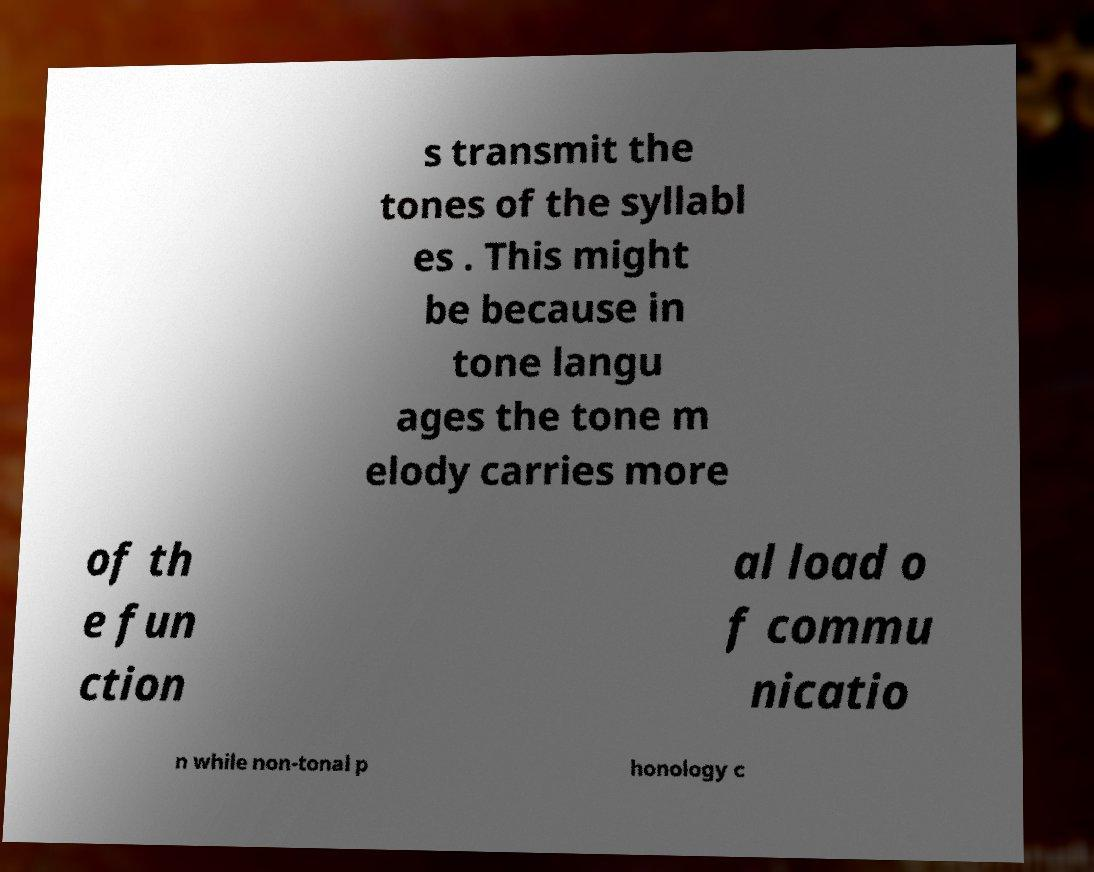Can you accurately transcribe the text from the provided image for me? s transmit the tones of the syllabl es . This might be because in tone langu ages the tone m elody carries more of th e fun ction al load o f commu nicatio n while non-tonal p honology c 